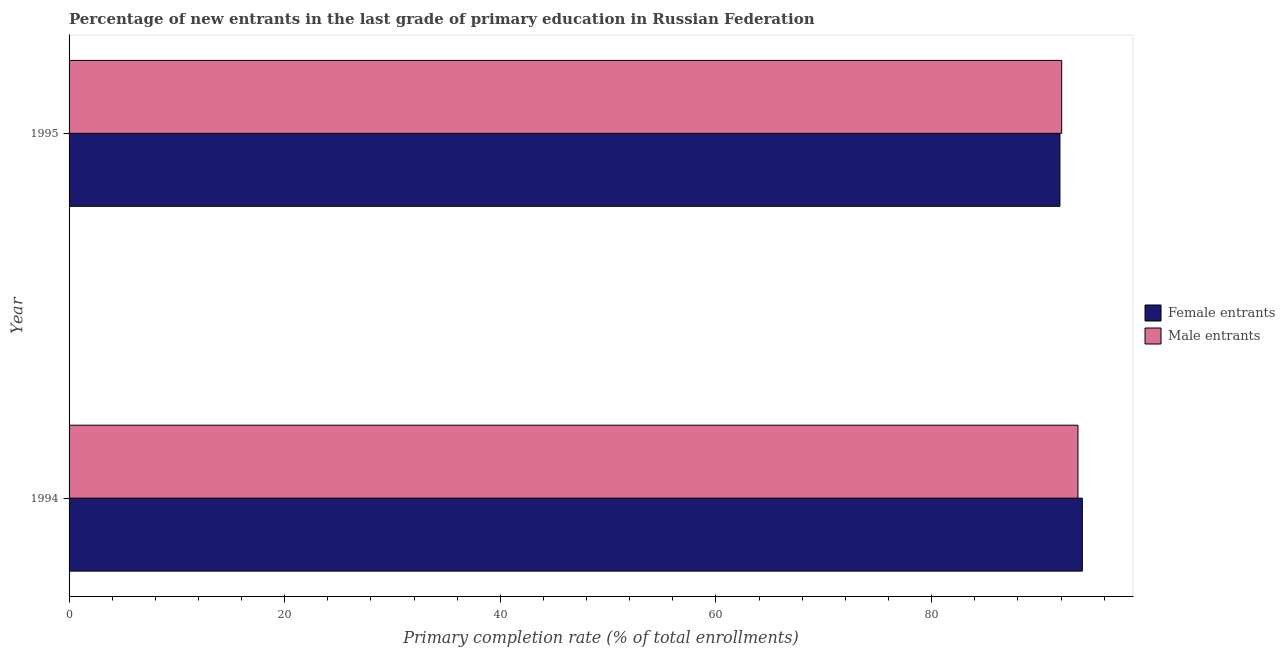How many groups of bars are there?
Provide a succinct answer. 2. Are the number of bars on each tick of the Y-axis equal?
Make the answer very short. Yes. How many bars are there on the 1st tick from the top?
Your response must be concise. 2. What is the primary completion rate of female entrants in 1994?
Your response must be concise. 93.98. Across all years, what is the maximum primary completion rate of male entrants?
Your answer should be very brief. 93.57. Across all years, what is the minimum primary completion rate of male entrants?
Your answer should be very brief. 92.06. In which year was the primary completion rate of male entrants maximum?
Your answer should be compact. 1994. In which year was the primary completion rate of female entrants minimum?
Ensure brevity in your answer.  1995. What is the total primary completion rate of female entrants in the graph?
Provide a succinct answer. 185.88. What is the difference between the primary completion rate of male entrants in 1994 and that in 1995?
Your response must be concise. 1.51. What is the difference between the primary completion rate of female entrants in 1995 and the primary completion rate of male entrants in 1994?
Offer a very short reply. -1.67. What is the average primary completion rate of male entrants per year?
Provide a short and direct response. 92.82. In the year 1994, what is the difference between the primary completion rate of male entrants and primary completion rate of female entrants?
Provide a succinct answer. -0.41. In how many years, is the primary completion rate of female entrants greater than the average primary completion rate of female entrants taken over all years?
Offer a terse response. 1. What does the 1st bar from the top in 1995 represents?
Your answer should be very brief. Male entrants. What does the 1st bar from the bottom in 1995 represents?
Keep it short and to the point. Female entrants. How many legend labels are there?
Your answer should be very brief. 2. How are the legend labels stacked?
Ensure brevity in your answer.  Vertical. What is the title of the graph?
Provide a short and direct response. Percentage of new entrants in the last grade of primary education in Russian Federation. Does "ODA received" appear as one of the legend labels in the graph?
Provide a succinct answer. No. What is the label or title of the X-axis?
Keep it short and to the point. Primary completion rate (% of total enrollments). What is the Primary completion rate (% of total enrollments) of Female entrants in 1994?
Give a very brief answer. 93.98. What is the Primary completion rate (% of total enrollments) of Male entrants in 1994?
Provide a succinct answer. 93.57. What is the Primary completion rate (% of total enrollments) of Female entrants in 1995?
Keep it short and to the point. 91.9. What is the Primary completion rate (% of total enrollments) in Male entrants in 1995?
Your response must be concise. 92.06. Across all years, what is the maximum Primary completion rate (% of total enrollments) of Female entrants?
Offer a very short reply. 93.98. Across all years, what is the maximum Primary completion rate (% of total enrollments) in Male entrants?
Keep it short and to the point. 93.57. Across all years, what is the minimum Primary completion rate (% of total enrollments) in Female entrants?
Provide a succinct answer. 91.9. Across all years, what is the minimum Primary completion rate (% of total enrollments) of Male entrants?
Ensure brevity in your answer.  92.06. What is the total Primary completion rate (% of total enrollments) of Female entrants in the graph?
Your answer should be compact. 185.88. What is the total Primary completion rate (% of total enrollments) in Male entrants in the graph?
Your response must be concise. 185.64. What is the difference between the Primary completion rate (% of total enrollments) in Female entrants in 1994 and that in 1995?
Your response must be concise. 2.08. What is the difference between the Primary completion rate (% of total enrollments) of Male entrants in 1994 and that in 1995?
Your response must be concise. 1.51. What is the difference between the Primary completion rate (% of total enrollments) in Female entrants in 1994 and the Primary completion rate (% of total enrollments) in Male entrants in 1995?
Ensure brevity in your answer.  1.92. What is the average Primary completion rate (% of total enrollments) in Female entrants per year?
Your answer should be compact. 92.94. What is the average Primary completion rate (% of total enrollments) of Male entrants per year?
Ensure brevity in your answer.  92.82. In the year 1994, what is the difference between the Primary completion rate (% of total enrollments) of Female entrants and Primary completion rate (% of total enrollments) of Male entrants?
Provide a short and direct response. 0.41. In the year 1995, what is the difference between the Primary completion rate (% of total enrollments) in Female entrants and Primary completion rate (% of total enrollments) in Male entrants?
Offer a terse response. -0.16. What is the ratio of the Primary completion rate (% of total enrollments) of Female entrants in 1994 to that in 1995?
Your answer should be very brief. 1.02. What is the ratio of the Primary completion rate (% of total enrollments) of Male entrants in 1994 to that in 1995?
Your response must be concise. 1.02. What is the difference between the highest and the second highest Primary completion rate (% of total enrollments) of Female entrants?
Offer a very short reply. 2.08. What is the difference between the highest and the second highest Primary completion rate (% of total enrollments) of Male entrants?
Make the answer very short. 1.51. What is the difference between the highest and the lowest Primary completion rate (% of total enrollments) of Female entrants?
Your response must be concise. 2.08. What is the difference between the highest and the lowest Primary completion rate (% of total enrollments) of Male entrants?
Your answer should be compact. 1.51. 